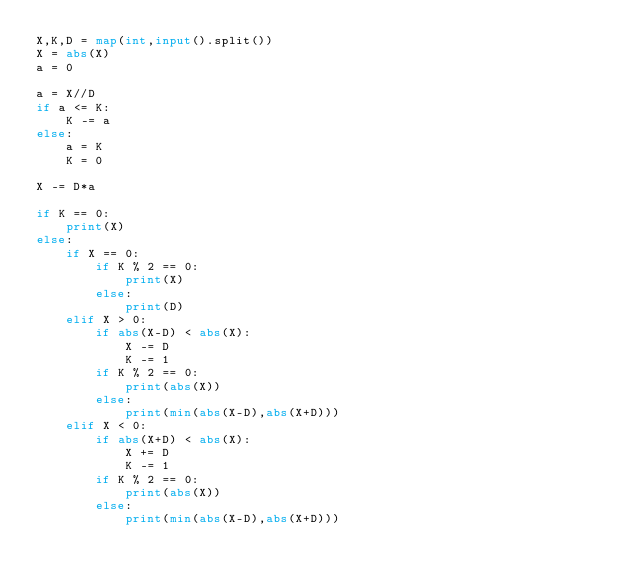<code> <loc_0><loc_0><loc_500><loc_500><_Python_>X,K,D = map(int,input().split())
X = abs(X)
a = 0

a = X//D
if a <= K:
    K -= a
else:
    a = K
    K = 0

X -= D*a
    
if K == 0:
    print(X)
else:
    if X == 0:
        if K % 2 == 0:
            print(X)
        else:
            print(D)
    elif X > 0:
        if abs(X-D) < abs(X):
            X -= D
            K -= 1
        if K % 2 == 0:
            print(abs(X))
        else:
            print(min(abs(X-D),abs(X+D)))
    elif X < 0:
        if abs(X+D) < abs(X):
            X += D
            K -= 1
        if K % 2 == 0:
            print(abs(X))
        else:
            print(min(abs(X-D),abs(X+D)))</code> 